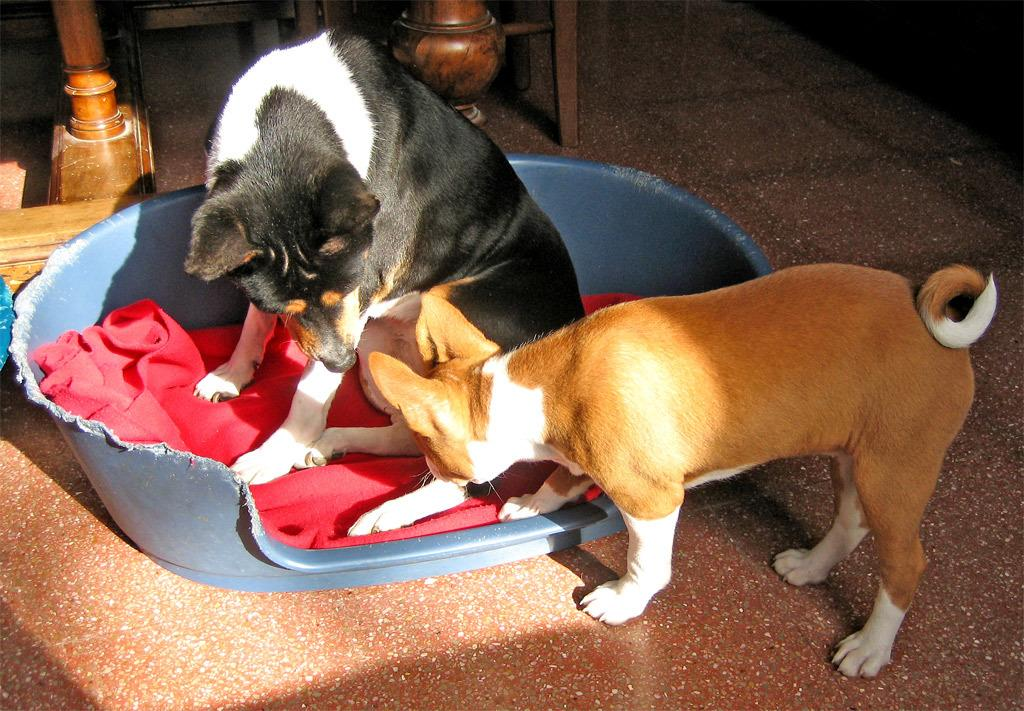How many dogs are present in the image? There are two dogs in the image. What is the position of one of the dogs? One of the dogs is sitting on a red cloth. Where is the red cloth located? The red cloth is placed in a tub. What type of objects can be seen at the top of the image? There are wooden objects visible at the top of the image. What type of insurance does the dog sitting on the red cloth have? There is no information about insurance in the image, as it focuses on the dogs and their surroundings. 